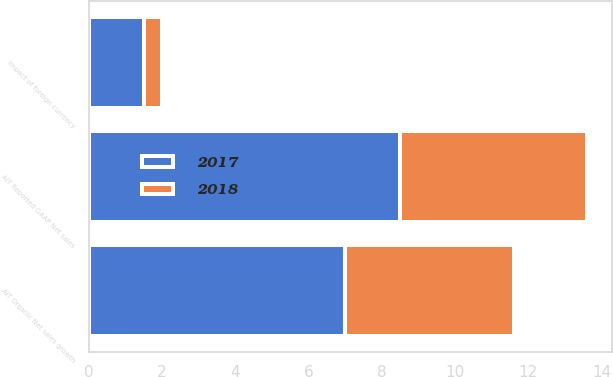Convert chart to OTSL. <chart><loc_0><loc_0><loc_500><loc_500><stacked_bar_chart><ecel><fcel>AIT Reported GAAP Net sales<fcel>Impact of foreign currency<fcel>AIT Organic Net sales growth<nl><fcel>2017<fcel>8.5<fcel>1.5<fcel>7<nl><fcel>2018<fcel>5.1<fcel>0.5<fcel>4.6<nl></chart> 